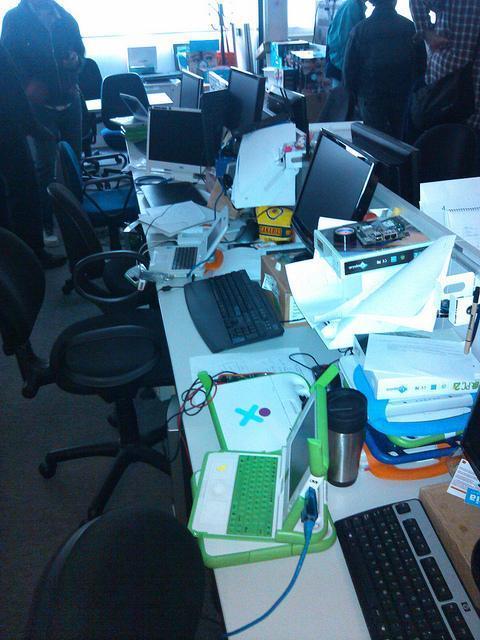How many keyboards are there?
Give a very brief answer. 3. How many laptops are there?
Give a very brief answer. 3. How many people are there?
Give a very brief answer. 4. How many chairs are in the picture?
Give a very brief answer. 5. How many tvs are there?
Give a very brief answer. 4. How many tracks have a train on them?
Give a very brief answer. 0. 